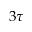<formula> <loc_0><loc_0><loc_500><loc_500>3 \tau</formula> 